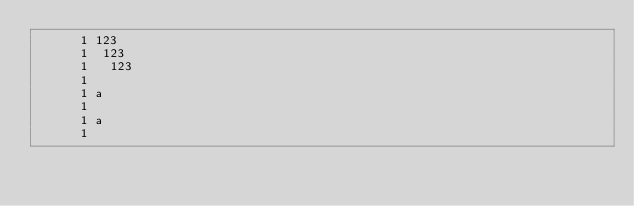<code> <loc_0><loc_0><loc_500><loc_500><_Cuda_>      1 123
      1  123
      1   123
      1 
      1 a
      1 
      1 a
      1  
</code> 